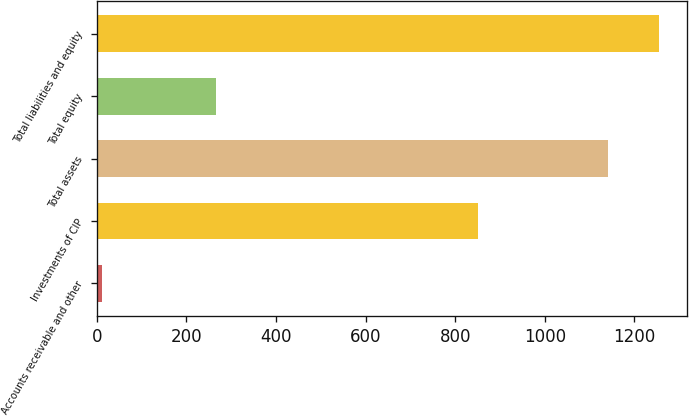<chart> <loc_0><loc_0><loc_500><loc_500><bar_chart><fcel>Accounts receivable and other<fcel>Investments of CIP<fcel>Total assets<fcel>Total equity<fcel>Total liabilities and equity<nl><fcel>11.5<fcel>851.8<fcel>1141.1<fcel>265.4<fcel>1254.06<nl></chart> 